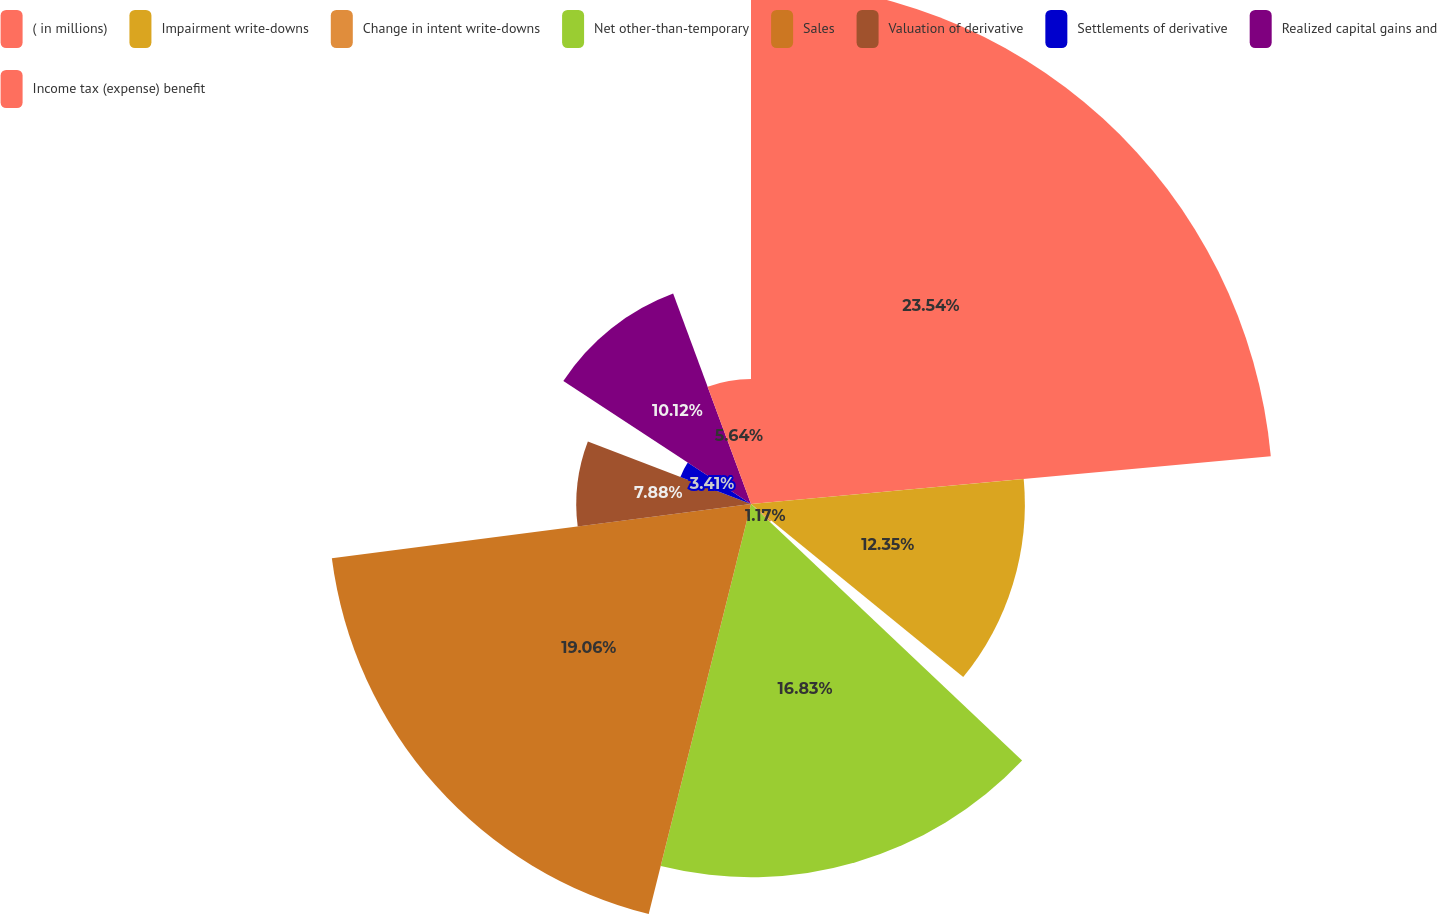<chart> <loc_0><loc_0><loc_500><loc_500><pie_chart><fcel>( in millions)<fcel>Impairment write-downs<fcel>Change in intent write-downs<fcel>Net other-than-temporary<fcel>Sales<fcel>Valuation of derivative<fcel>Settlements of derivative<fcel>Realized capital gains and<fcel>Income tax (expense) benefit<nl><fcel>23.54%<fcel>12.35%<fcel>1.17%<fcel>16.83%<fcel>19.06%<fcel>7.88%<fcel>3.41%<fcel>10.12%<fcel>5.64%<nl></chart> 